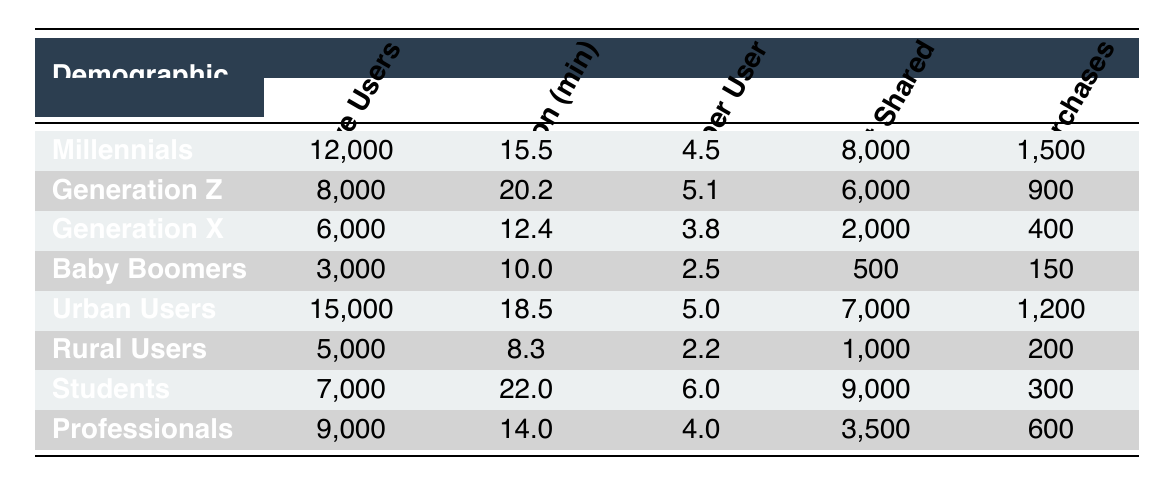What is the average session duration for Millennials? The table shows that the average session duration for Millennials is 15.5 minutes.
Answer: 15.5 How many active users are there in the Urban Users demographic segment? According to the table, there are 15,000 active users in the Urban Users segment.
Answer: 15,000 Which demographic segment has the highest content shared? The table indicates that Students have the highest content shared at 9,000.
Answer: Students What is the total number of in-app purchases for all demographic segments? Adding up the in-app purchases from all groups: 1,500 + 900 + 400 + 150 + 1,200 + 200 + 300 + 600 = 5,300.
Answer: 5,300 Is the average session duration for Generation Z greater than that of Generation X? The average session duration for Generation Z is 20.2 minutes, while for Generation X it is 12.4 minutes, so yes, it is greater.
Answer: Yes What is the difference in active users between Millennials and Baby Boomers? The difference is calculated by subtracting the active users of Baby Boomers (3,000) from Millennials (12,000), giving us 12,000 - 3,000 = 9,000.
Answer: 9,000 Which demographic segment has the lowest sessions per user? The lowest sessions per user is recorded for Baby Boomers at 2.5.
Answer: Baby Boomers What is the total average session duration for all user segments combined? To find the total average session duration, first sum the durations: 15.5 + 20.2 + 12.4 + 10.0 + 18.5 + 8.3 + 22.0 + 14.0 = 117.9 minutes; the average is 117.9 / 8 = 14.7375 minutes.
Answer: 14.74 Are there more active users among Urban Users or Generation Z? Urban Users have 15,000 active users while Generation Z has 8,000, thus Urban Users have more.
Answer: Urban Users What is the average number of sessions per user for the Students demographic segment? The average number of sessions per user for the Students is 6.0, as stated in the table.
Answer: 6.0 